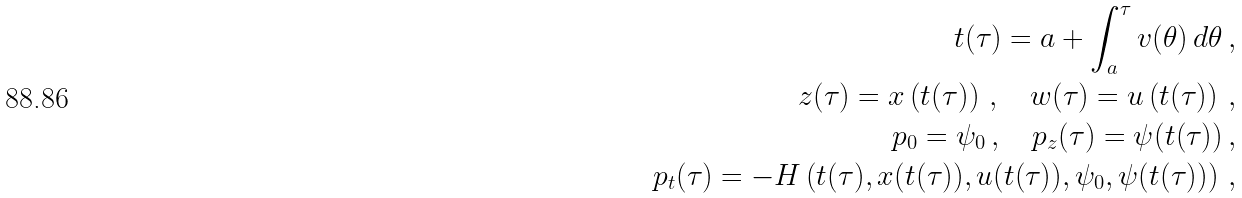Convert formula to latex. <formula><loc_0><loc_0><loc_500><loc_500>t ( \tau ) = a + \int _ { a } ^ { \tau } v ( \theta ) \, d \theta \, , \\ z ( \tau ) = x \left ( t ( \tau ) \right ) \, , \quad w ( \tau ) = u \left ( t ( \tau ) \right ) \, , \\ p _ { 0 } = \psi _ { 0 } \, , \quad p _ { z } ( \tau ) = \psi ( t ( \tau ) ) \, , \\ p _ { t } ( \tau ) = - H \left ( t ( \tau ) , x ( t ( \tau ) ) , u ( t ( \tau ) ) , \psi _ { 0 } , \psi ( t ( \tau ) ) \right ) \, ,</formula> 